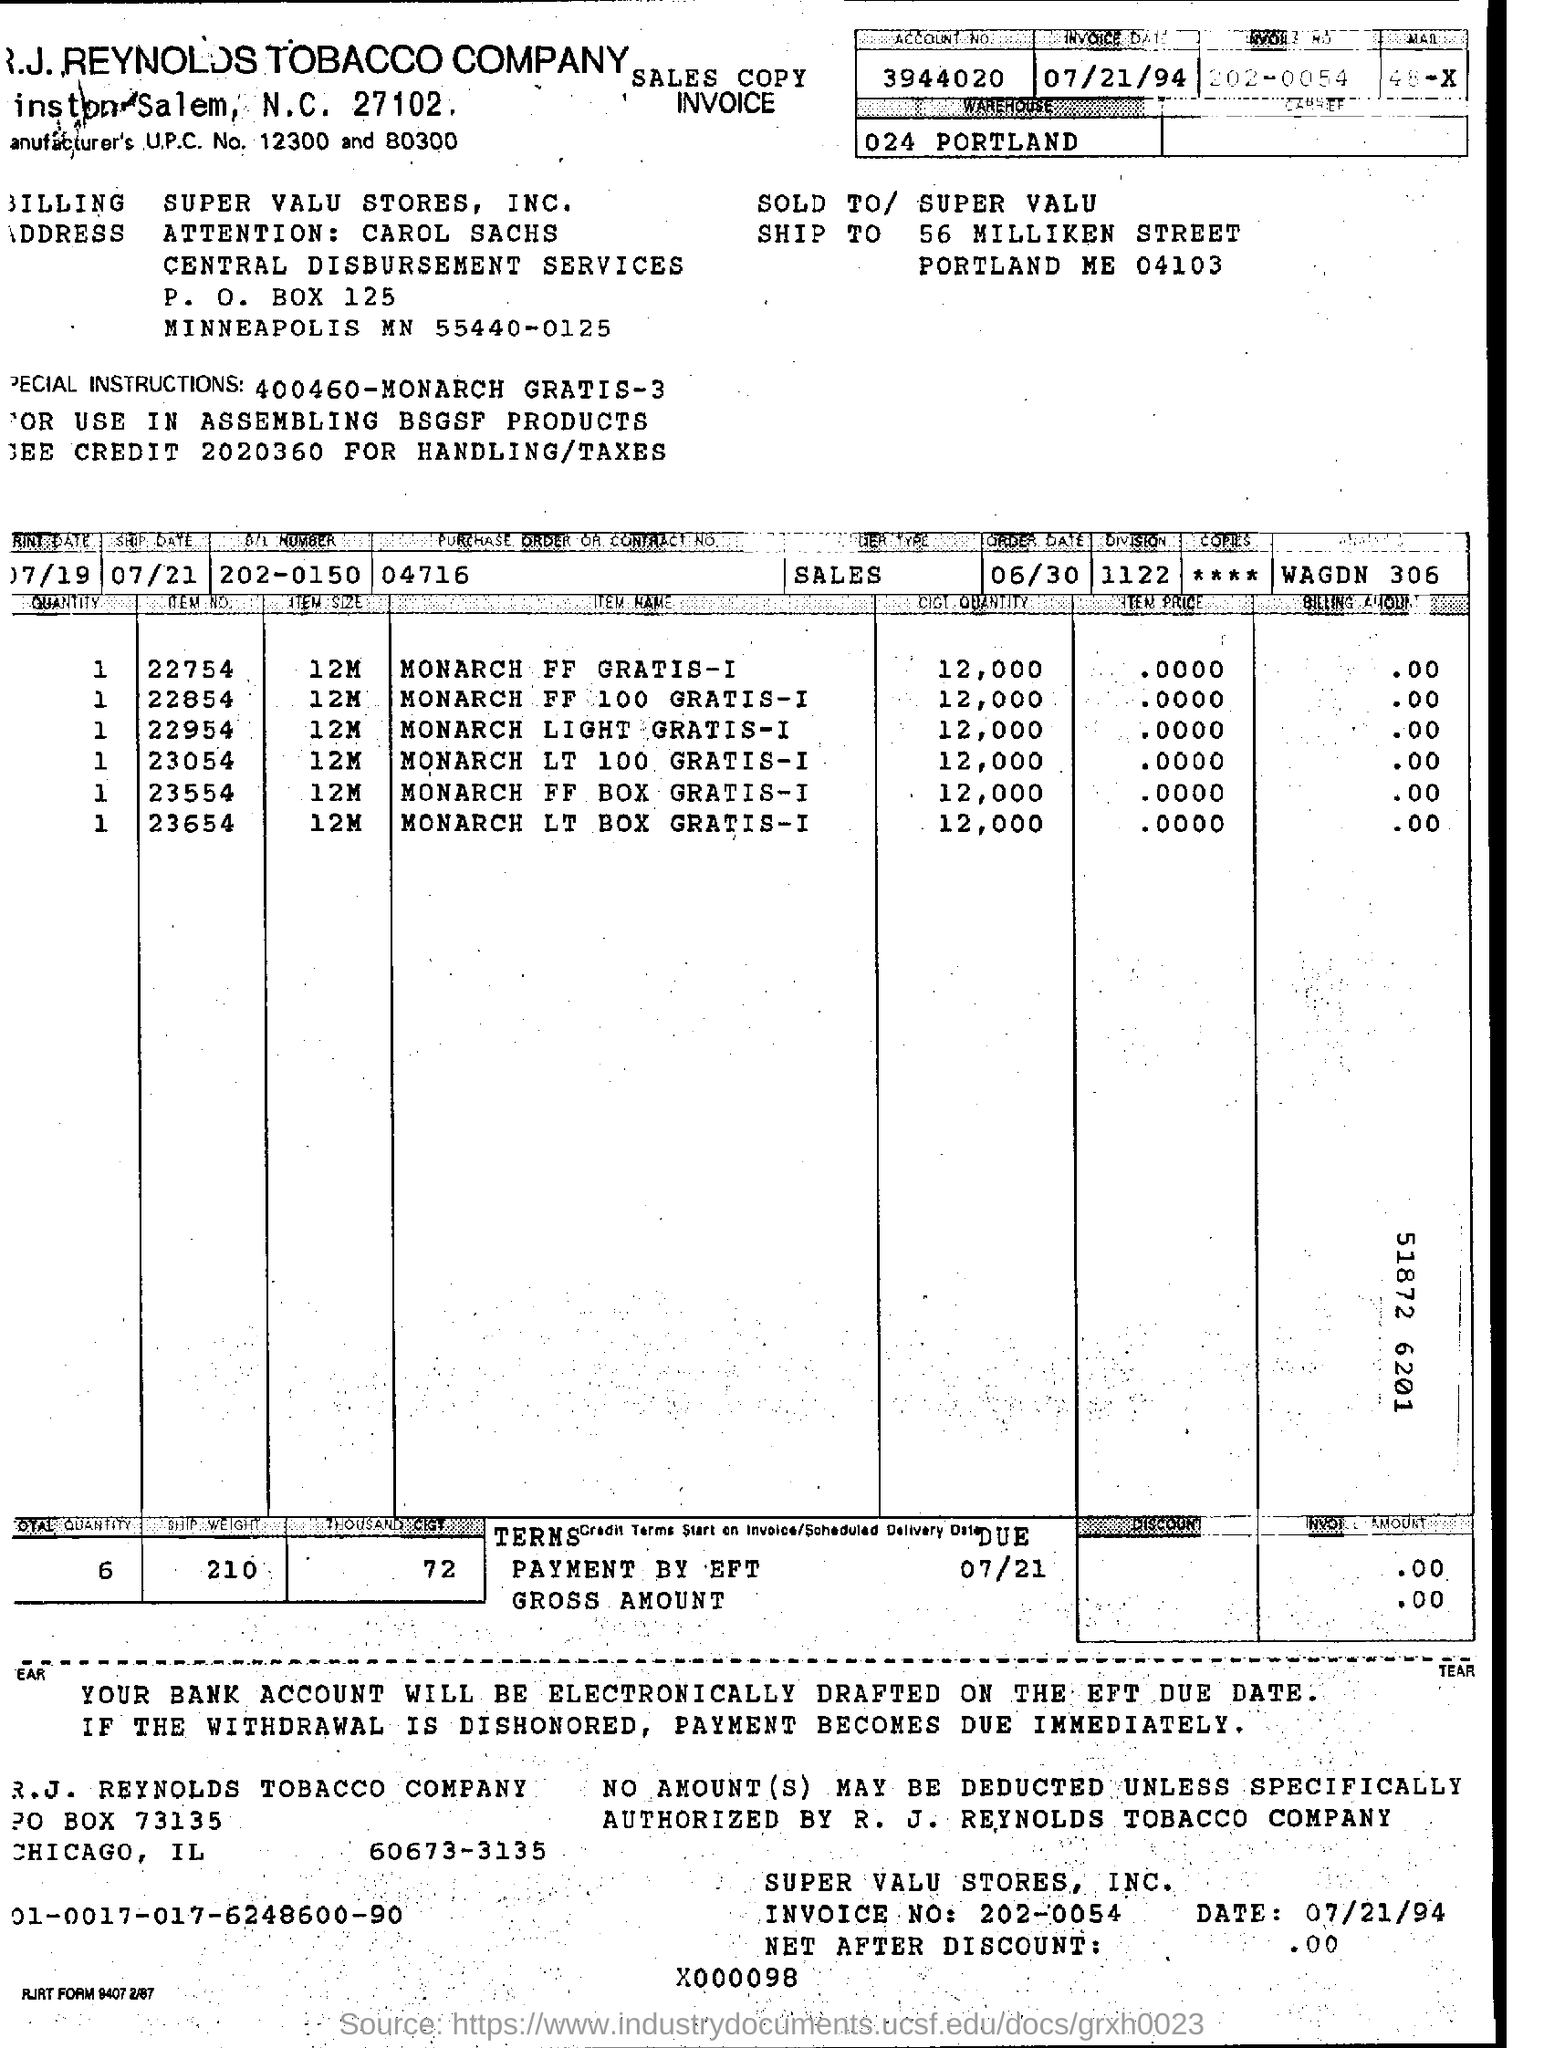What is the invoice date?
Your answer should be compact. 07/21/94. 